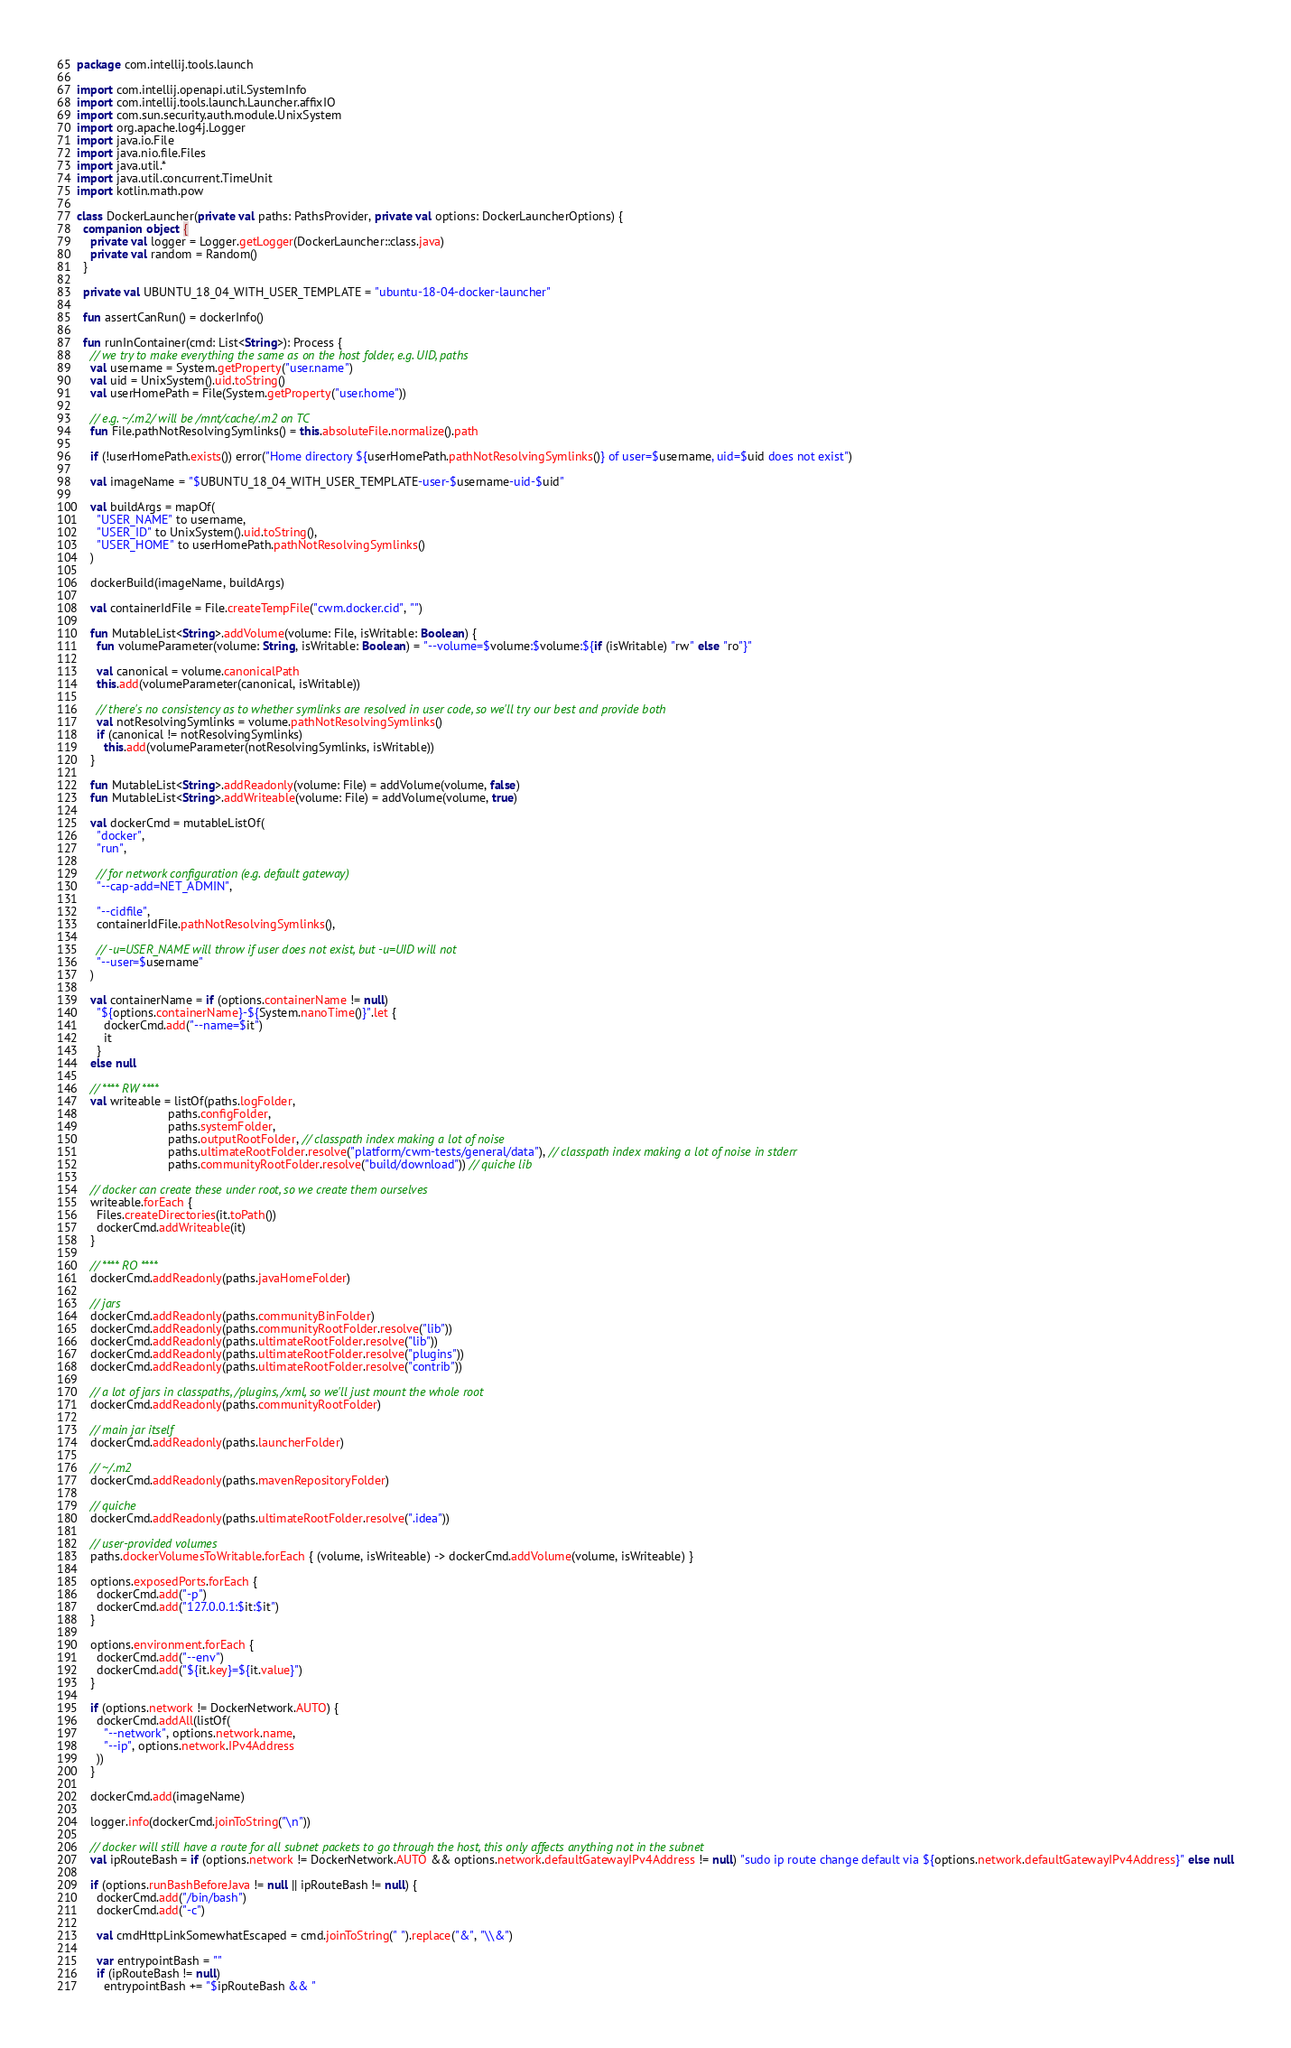Convert code to text. <code><loc_0><loc_0><loc_500><loc_500><_Kotlin_>package com.intellij.tools.launch

import com.intellij.openapi.util.SystemInfo
import com.intellij.tools.launch.Launcher.affixIO
import com.sun.security.auth.module.UnixSystem
import org.apache.log4j.Logger
import java.io.File
import java.nio.file.Files
import java.util.*
import java.util.concurrent.TimeUnit
import kotlin.math.pow

class DockerLauncher(private val paths: PathsProvider, private val options: DockerLauncherOptions) {
  companion object {
    private val logger = Logger.getLogger(DockerLauncher::class.java)
    private val random = Random()
  }

  private val UBUNTU_18_04_WITH_USER_TEMPLATE = "ubuntu-18-04-docker-launcher"

  fun assertCanRun() = dockerInfo()

  fun runInContainer(cmd: List<String>): Process {
    // we try to make everything the same as on the host folder, e.g. UID, paths
    val username = System.getProperty("user.name")
    val uid = UnixSystem().uid.toString()
    val userHomePath = File(System.getProperty("user.home"))

    // e.g. ~/.m2/ will be /mnt/cache/.m2 on TC
    fun File.pathNotResolvingSymlinks() = this.absoluteFile.normalize().path

    if (!userHomePath.exists()) error("Home directory ${userHomePath.pathNotResolvingSymlinks()} of user=$username, uid=$uid does not exist")

    val imageName = "$UBUNTU_18_04_WITH_USER_TEMPLATE-user-$username-uid-$uid"

    val buildArgs = mapOf(
      "USER_NAME" to username,
      "USER_ID" to UnixSystem().uid.toString(),
      "USER_HOME" to userHomePath.pathNotResolvingSymlinks()
    )

    dockerBuild(imageName, buildArgs)

    val containerIdFile = File.createTempFile("cwm.docker.cid", "")

    fun MutableList<String>.addVolume(volume: File, isWritable: Boolean) {
      fun volumeParameter(volume: String, isWritable: Boolean) = "--volume=$volume:$volume:${if (isWritable) "rw" else "ro"}"

      val canonical = volume.canonicalPath
      this.add(volumeParameter(canonical, isWritable))

      // there's no consistency as to whether symlinks are resolved in user code, so we'll try our best and provide both
      val notResolvingSymlinks = volume.pathNotResolvingSymlinks()
      if (canonical != notResolvingSymlinks)
        this.add(volumeParameter(notResolvingSymlinks, isWritable))
    }

    fun MutableList<String>.addReadonly(volume: File) = addVolume(volume, false)
    fun MutableList<String>.addWriteable(volume: File) = addVolume(volume, true)

    val dockerCmd = mutableListOf(
      "docker",
      "run",

      // for network configuration (e.g. default gateway)
      "--cap-add=NET_ADMIN",

      "--cidfile",
      containerIdFile.pathNotResolvingSymlinks(),

      // -u=USER_NAME will throw if user does not exist, but -u=UID will not
      "--user=$username"
    )

    val containerName = if (options.containerName != null)
      "${options.containerName}-${System.nanoTime()}".let {
        dockerCmd.add("--name=$it")
        it
      }
    else null

    // **** RW ****
    val writeable = listOf(paths.logFolder,
                           paths.configFolder,
                           paths.systemFolder,
                           paths.outputRootFolder, // classpath index making a lot of noise
                           paths.ultimateRootFolder.resolve("platform/cwm-tests/general/data"), // classpath index making a lot of noise in stderr
                           paths.communityRootFolder.resolve("build/download")) // quiche lib

    // docker can create these under root, so we create them ourselves
    writeable.forEach {
      Files.createDirectories(it.toPath())
      dockerCmd.addWriteable(it)
    }

    // **** RO ****
    dockerCmd.addReadonly(paths.javaHomeFolder)

    // jars
    dockerCmd.addReadonly(paths.communityBinFolder)
    dockerCmd.addReadonly(paths.communityRootFolder.resolve("lib"))
    dockerCmd.addReadonly(paths.ultimateRootFolder.resolve("lib"))
    dockerCmd.addReadonly(paths.ultimateRootFolder.resolve("plugins"))
    dockerCmd.addReadonly(paths.ultimateRootFolder.resolve("contrib"))

    // a lot of jars in classpaths, /plugins, /xml, so we'll just mount the whole root
    dockerCmd.addReadonly(paths.communityRootFolder)

    // main jar itself
    dockerCmd.addReadonly(paths.launcherFolder)

    // ~/.m2
    dockerCmd.addReadonly(paths.mavenRepositoryFolder)
    
    // quiche
    dockerCmd.addReadonly(paths.ultimateRootFolder.resolve(".idea"))

    // user-provided volumes
    paths.dockerVolumesToWritable.forEach { (volume, isWriteable) -> dockerCmd.addVolume(volume, isWriteable) }

    options.exposedPorts.forEach {
      dockerCmd.add("-p")
      dockerCmd.add("127.0.0.1:$it:$it")
    }

    options.environment.forEach {
      dockerCmd.add("--env")
      dockerCmd.add("${it.key}=${it.value}")
    }

    if (options.network != DockerNetwork.AUTO) {
      dockerCmd.addAll(listOf(
        "--network", options.network.name,
        "--ip", options.network.IPv4Address
      ))
    }

    dockerCmd.add(imageName)

    logger.info(dockerCmd.joinToString("\n"))

    // docker will still have a route for all subnet packets to go through the host, this only affects anything not in the subnet
    val ipRouteBash = if (options.network != DockerNetwork.AUTO && options.network.defaultGatewayIPv4Address != null) "sudo ip route change default via ${options.network.defaultGatewayIPv4Address}" else null

    if (options.runBashBeforeJava != null || ipRouteBash != null) {
      dockerCmd.add("/bin/bash")
      dockerCmd.add("-c")

      val cmdHttpLinkSomewhatEscaped = cmd.joinToString(" ").replace("&", "\\&")

      var entrypointBash = ""
      if (ipRouteBash != null)
        entrypointBash += "$ipRouteBash && "</code> 